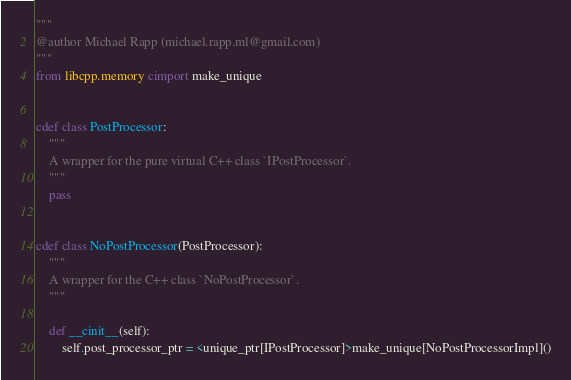Convert code to text. <code><loc_0><loc_0><loc_500><loc_500><_Cython_>"""
@author Michael Rapp (michael.rapp.ml@gmail.com)
"""
from libcpp.memory cimport make_unique


cdef class PostProcessor:
    """
    A wrapper for the pure virtual C++ class `IPostProcessor`.
    """
    pass


cdef class NoPostProcessor(PostProcessor):
    """
    A wrapper for the C++ class `NoPostProcessor`.
    """

    def __cinit__(self):
        self.post_processor_ptr = <unique_ptr[IPostProcessor]>make_unique[NoPostProcessorImpl]()
</code> 